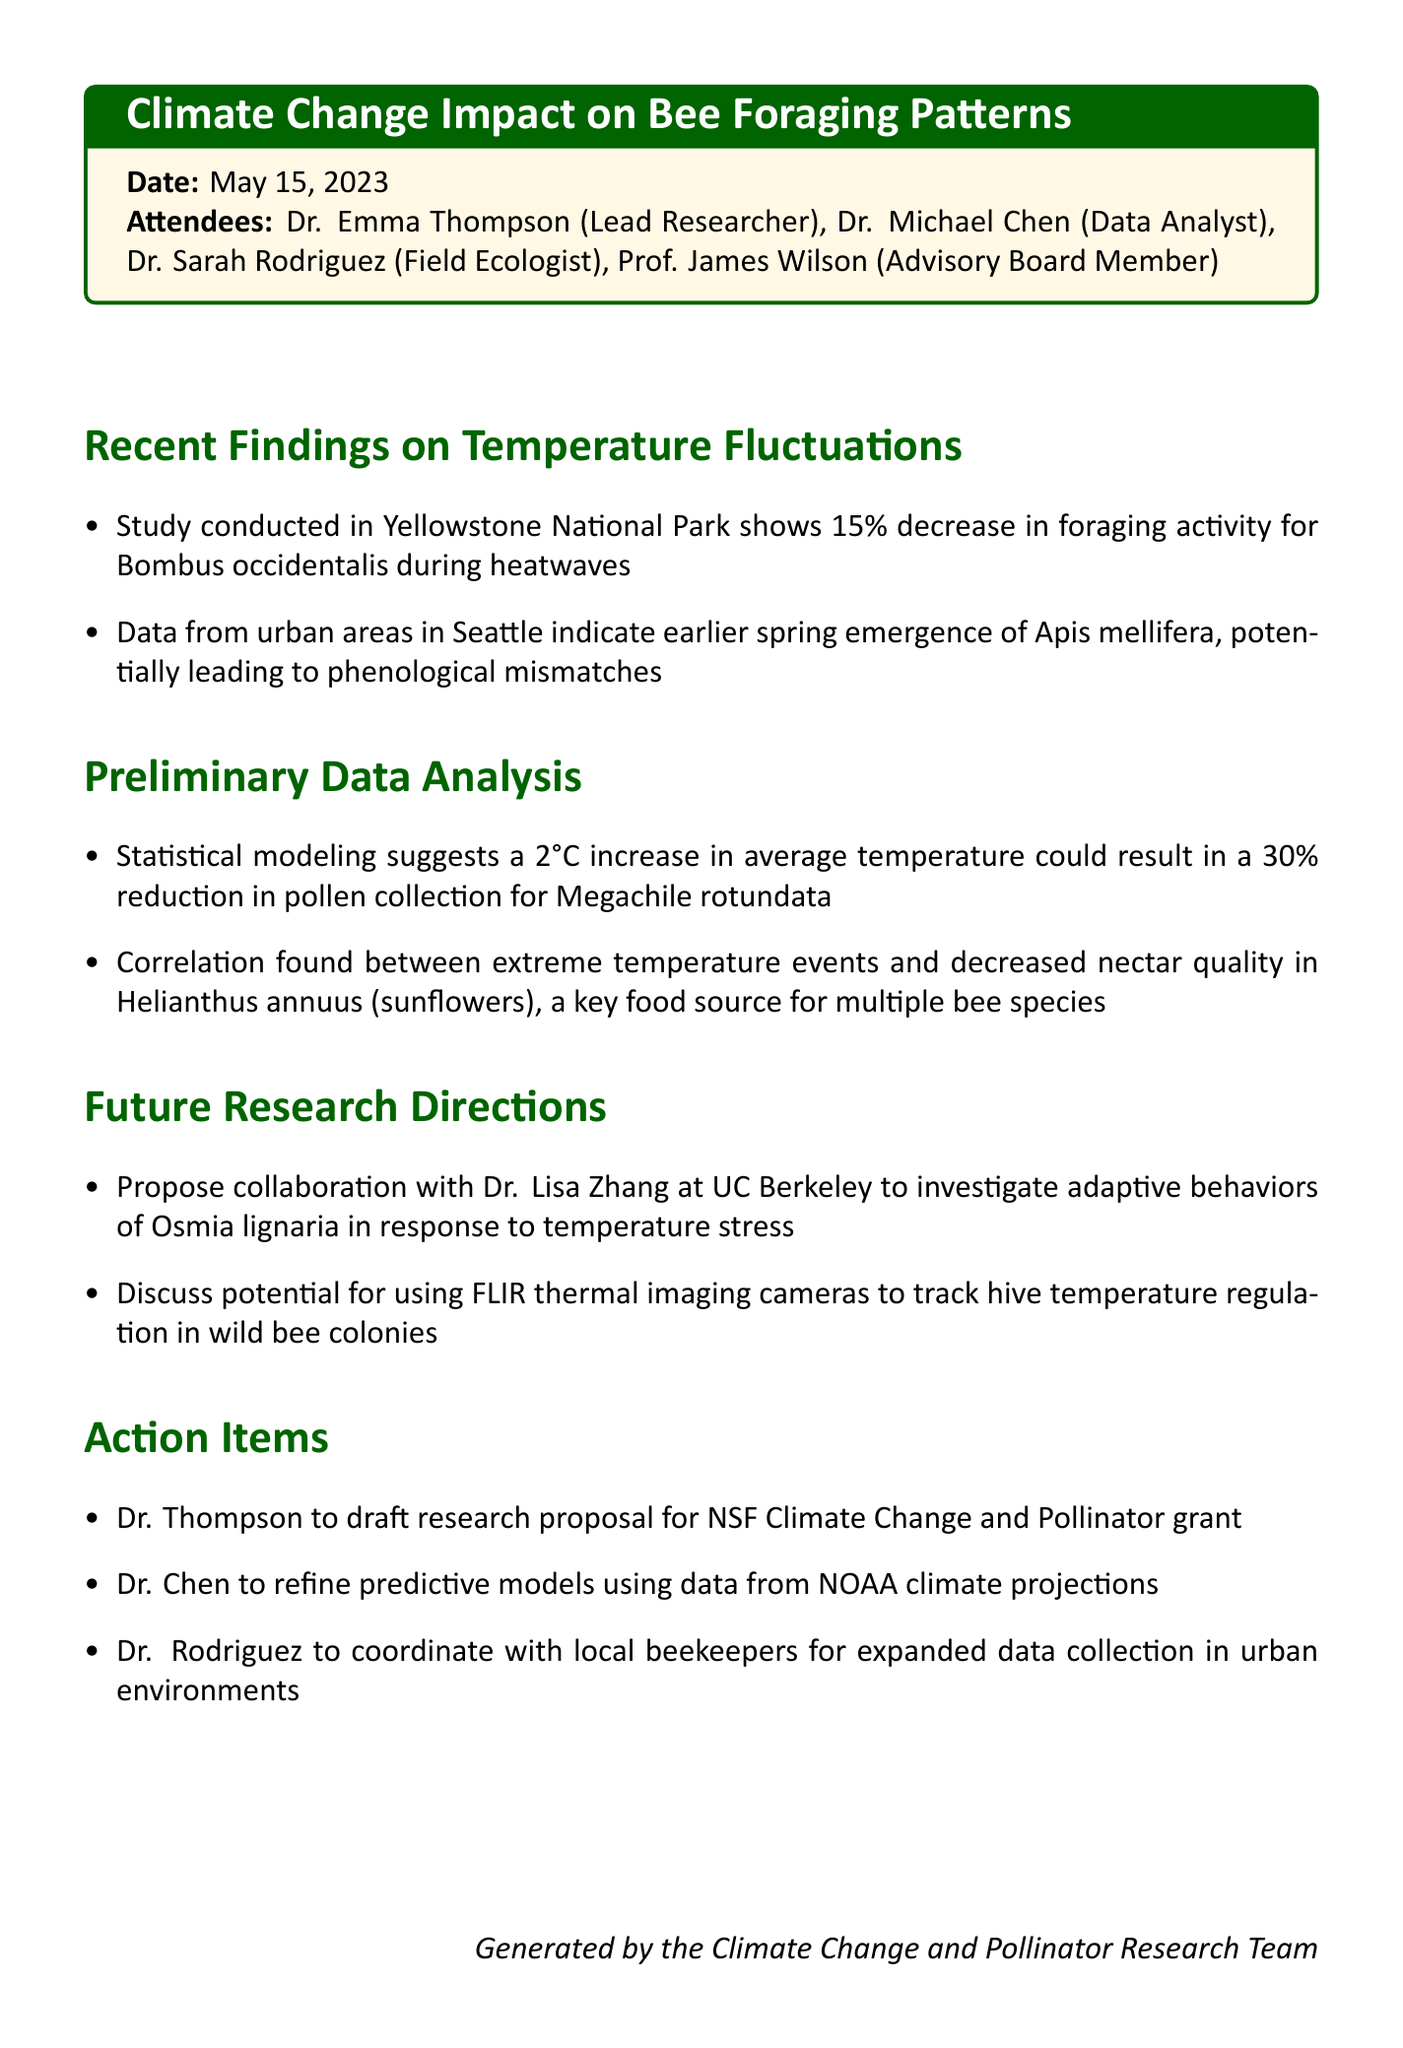What is the date of the meeting? The date of the meeting is explicitly mentioned in the document.
Answer: May 15, 2023 Who is the lead researcher? The lead researcher is listed among the attendees at the beginning of the document.
Answer: Dr. Emma Thompson What percentage decrease in foraging activity was observed during heatwaves? This information is found in the section discussing recent findings.
Answer: 15% What is the proposed temperature increase that could reduce pollen collection for Megachile rotundata? The document specifies the temperature increase in the preliminary data analysis section.
Answer: 2°C Which bee species had their spring emergence occur earlier in urban areas? The document details the species in the findings section.
Answer: Apis mellifera What is one method proposed for tracking hive temperature regulation? This method is discussed in the future research directions.
Answer: FLIR thermal imaging cameras Who will coordinate with local beekeepers for data collection? The action items list who is responsible for this task.
Answer: Dr. Rodriguez What collaboration is proposed to investigate adaptive behaviors of Osmia lignaria? The collaborative effort is mentioned in the future research directions.
Answer: Dr. Lisa Zhang at UC Berkeley 